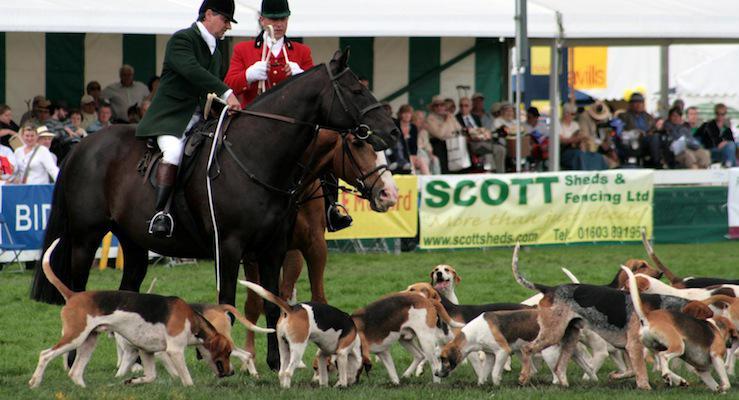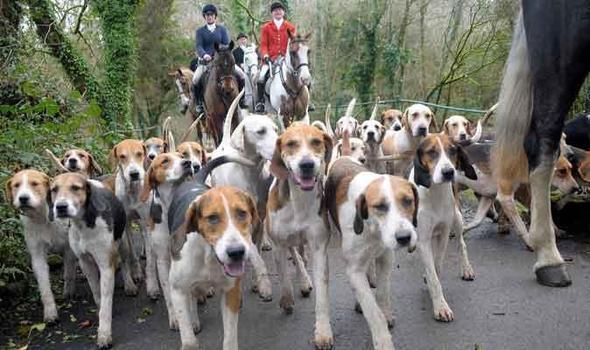The first image is the image on the left, the second image is the image on the right. Given the left and right images, does the statement "A man in green jacket, equestrian cap and white pants is astride a horse in the foreground of one image." hold true? Answer yes or no. Yes. The first image is the image on the left, the second image is the image on the right. Examine the images to the left and right. Is the description "At least four riders are on horses near the dogs." accurate? Answer yes or no. Yes. 